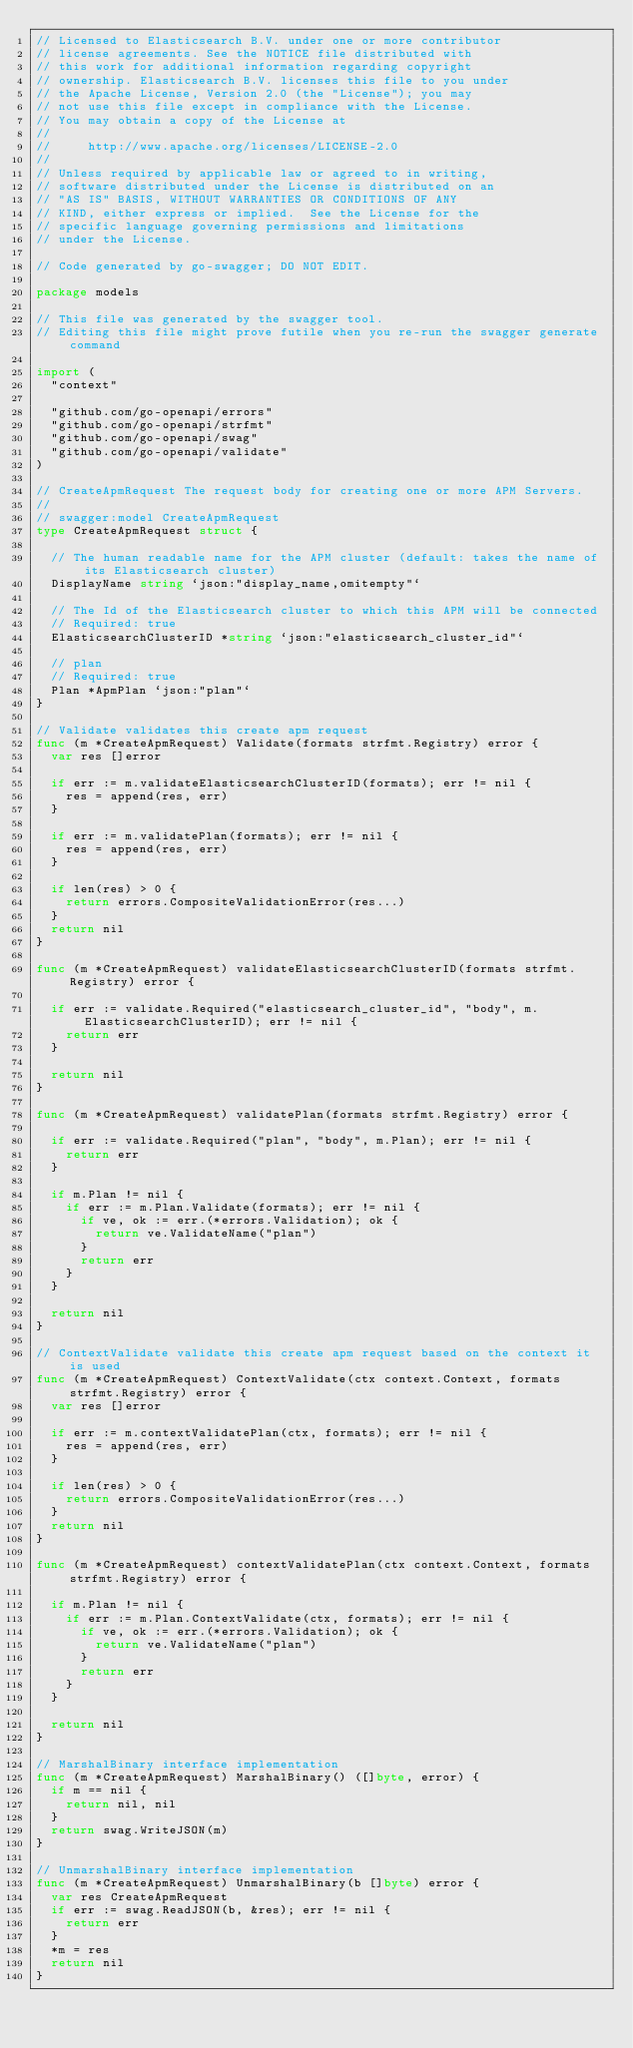Convert code to text. <code><loc_0><loc_0><loc_500><loc_500><_Go_>// Licensed to Elasticsearch B.V. under one or more contributor
// license agreements. See the NOTICE file distributed with
// this work for additional information regarding copyright
// ownership. Elasticsearch B.V. licenses this file to you under
// the Apache License, Version 2.0 (the "License"); you may
// not use this file except in compliance with the License.
// You may obtain a copy of the License at
//
//     http://www.apache.org/licenses/LICENSE-2.0
//
// Unless required by applicable law or agreed to in writing,
// software distributed under the License is distributed on an
// "AS IS" BASIS, WITHOUT WARRANTIES OR CONDITIONS OF ANY
// KIND, either express or implied.  See the License for the
// specific language governing permissions and limitations
// under the License.

// Code generated by go-swagger; DO NOT EDIT.

package models

// This file was generated by the swagger tool.
// Editing this file might prove futile when you re-run the swagger generate command

import (
	"context"

	"github.com/go-openapi/errors"
	"github.com/go-openapi/strfmt"
	"github.com/go-openapi/swag"
	"github.com/go-openapi/validate"
)

// CreateApmRequest The request body for creating one or more APM Servers.
//
// swagger:model CreateApmRequest
type CreateApmRequest struct {

	// The human readable name for the APM cluster (default: takes the name of its Elasticsearch cluster)
	DisplayName string `json:"display_name,omitempty"`

	// The Id of the Elasticsearch cluster to which this APM will be connected
	// Required: true
	ElasticsearchClusterID *string `json:"elasticsearch_cluster_id"`

	// plan
	// Required: true
	Plan *ApmPlan `json:"plan"`
}

// Validate validates this create apm request
func (m *CreateApmRequest) Validate(formats strfmt.Registry) error {
	var res []error

	if err := m.validateElasticsearchClusterID(formats); err != nil {
		res = append(res, err)
	}

	if err := m.validatePlan(formats); err != nil {
		res = append(res, err)
	}

	if len(res) > 0 {
		return errors.CompositeValidationError(res...)
	}
	return nil
}

func (m *CreateApmRequest) validateElasticsearchClusterID(formats strfmt.Registry) error {

	if err := validate.Required("elasticsearch_cluster_id", "body", m.ElasticsearchClusterID); err != nil {
		return err
	}

	return nil
}

func (m *CreateApmRequest) validatePlan(formats strfmt.Registry) error {

	if err := validate.Required("plan", "body", m.Plan); err != nil {
		return err
	}

	if m.Plan != nil {
		if err := m.Plan.Validate(formats); err != nil {
			if ve, ok := err.(*errors.Validation); ok {
				return ve.ValidateName("plan")
			}
			return err
		}
	}

	return nil
}

// ContextValidate validate this create apm request based on the context it is used
func (m *CreateApmRequest) ContextValidate(ctx context.Context, formats strfmt.Registry) error {
	var res []error

	if err := m.contextValidatePlan(ctx, formats); err != nil {
		res = append(res, err)
	}

	if len(res) > 0 {
		return errors.CompositeValidationError(res...)
	}
	return nil
}

func (m *CreateApmRequest) contextValidatePlan(ctx context.Context, formats strfmt.Registry) error {

	if m.Plan != nil {
		if err := m.Plan.ContextValidate(ctx, formats); err != nil {
			if ve, ok := err.(*errors.Validation); ok {
				return ve.ValidateName("plan")
			}
			return err
		}
	}

	return nil
}

// MarshalBinary interface implementation
func (m *CreateApmRequest) MarshalBinary() ([]byte, error) {
	if m == nil {
		return nil, nil
	}
	return swag.WriteJSON(m)
}

// UnmarshalBinary interface implementation
func (m *CreateApmRequest) UnmarshalBinary(b []byte) error {
	var res CreateApmRequest
	if err := swag.ReadJSON(b, &res); err != nil {
		return err
	}
	*m = res
	return nil
}
</code> 